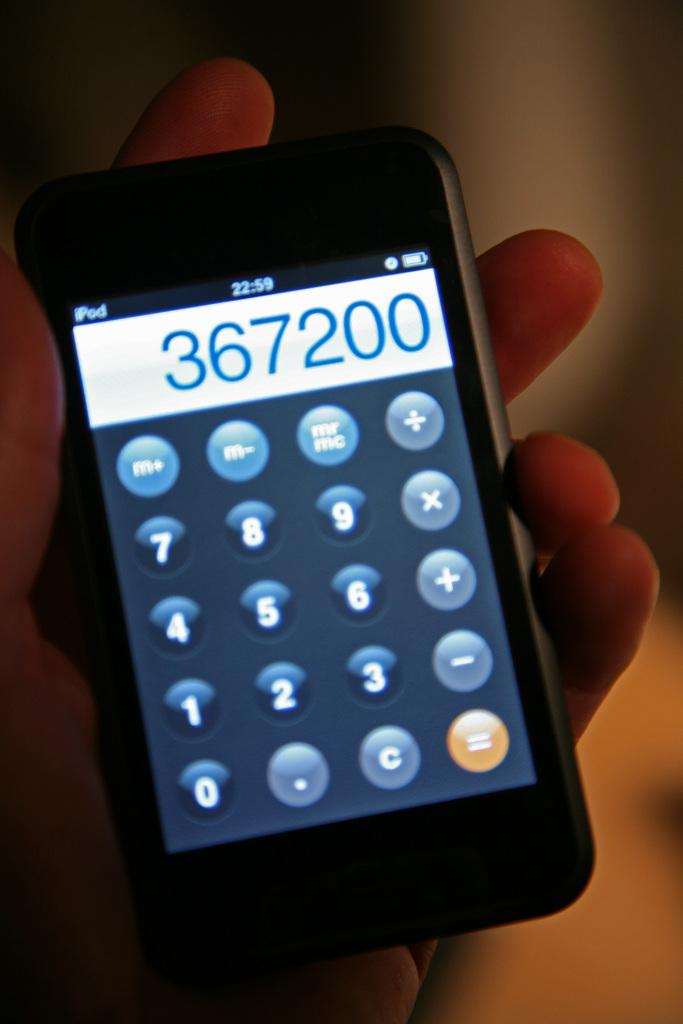<image>
Present a compact description of the photo's key features. a phone is displayed with the numbers 367200 written in a calculator app 